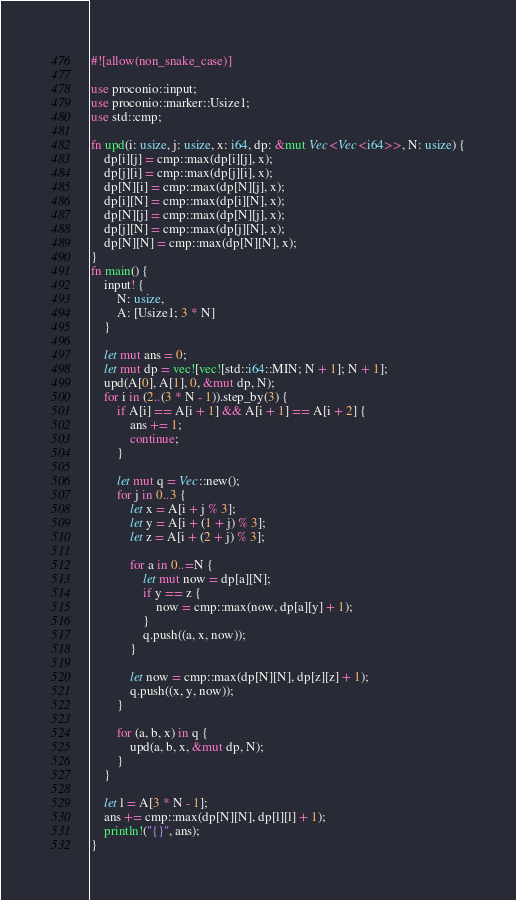Convert code to text. <code><loc_0><loc_0><loc_500><loc_500><_Rust_>#![allow(non_snake_case)]

use proconio::input;
use proconio::marker::Usize1;
use std::cmp;

fn upd(i: usize, j: usize, x: i64, dp: &mut Vec<Vec<i64>>, N: usize) {
    dp[i][j] = cmp::max(dp[i][j], x);
    dp[j][i] = cmp::max(dp[j][i], x);
    dp[N][i] = cmp::max(dp[N][j], x);
    dp[i][N] = cmp::max(dp[i][N], x);
    dp[N][j] = cmp::max(dp[N][j], x);
    dp[j][N] = cmp::max(dp[j][N], x);
    dp[N][N] = cmp::max(dp[N][N], x);
}
fn main() {
    input! {
        N: usize,
        A: [Usize1; 3 * N]
    }

    let mut ans = 0;
    let mut dp = vec![vec![std::i64::MIN; N + 1]; N + 1];
    upd(A[0], A[1], 0, &mut dp, N);
    for i in (2..(3 * N - 1)).step_by(3) {
        if A[i] == A[i + 1] && A[i + 1] == A[i + 2] {
            ans += 1;
            continue;
        }

        let mut q = Vec::new();
        for j in 0..3 {
            let x = A[i + j % 3];
            let y = A[i + (1 + j) % 3];
            let z = A[i + (2 + j) % 3];

            for a in 0..=N {
                let mut now = dp[a][N];
                if y == z {
                    now = cmp::max(now, dp[a][y] + 1);
                }
                q.push((a, x, now));
            }

            let now = cmp::max(dp[N][N], dp[z][z] + 1);
            q.push((x, y, now));
        }

        for (a, b, x) in q {
            upd(a, b, x, &mut dp, N);
        }
    }

    let l = A[3 * N - 1];
    ans += cmp::max(dp[N][N], dp[l][l] + 1);
    println!("{}", ans);
}
</code> 